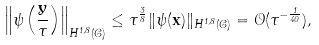<formula> <loc_0><loc_0><loc_500><loc_500>\left \| \psi \left ( \frac { \mathbf y } { \tau } \right ) \right \| _ { H ^ { 1 , 8 } ( \mathcal { C } ) } \leq \tau ^ { \frac { 3 } { 8 } } \| \psi ( \mathbf x ) \| _ { H ^ { 1 , 8 } ( \mathcal { C } ) } = \mathcal { O } ( \tau ^ { - \frac { 1 } { 4 0 } } ) ,</formula> 